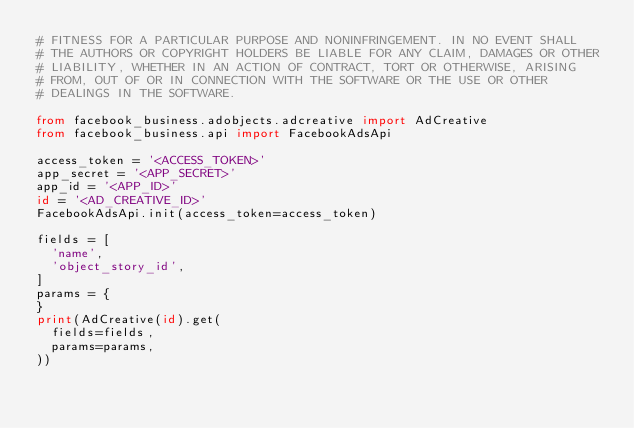Convert code to text. <code><loc_0><loc_0><loc_500><loc_500><_Python_># FITNESS FOR A PARTICULAR PURPOSE AND NONINFRINGEMENT. IN NO EVENT SHALL
# THE AUTHORS OR COPYRIGHT HOLDERS BE LIABLE FOR ANY CLAIM, DAMAGES OR OTHER
# LIABILITY, WHETHER IN AN ACTION OF CONTRACT, TORT OR OTHERWISE, ARISING
# FROM, OUT OF OR IN CONNECTION WITH THE SOFTWARE OR THE USE OR OTHER
# DEALINGS IN THE SOFTWARE.

from facebook_business.adobjects.adcreative import AdCreative
from facebook_business.api import FacebookAdsApi

access_token = '<ACCESS_TOKEN>'
app_secret = '<APP_SECRET>'
app_id = '<APP_ID>'
id = '<AD_CREATIVE_ID>'
FacebookAdsApi.init(access_token=access_token)

fields = [
  'name',
  'object_story_id',
]
params = {
}
print(AdCreative(id).get(
  fields=fields,
  params=params,
))</code> 